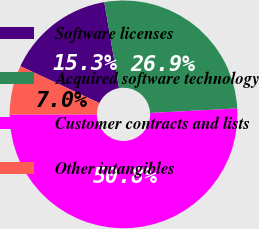Convert chart. <chart><loc_0><loc_0><loc_500><loc_500><pie_chart><fcel>Software licenses<fcel>Acquired software technology<fcel>Customer contracts and lists<fcel>Other intangibles<nl><fcel>15.35%<fcel>26.87%<fcel>50.8%<fcel>6.98%<nl></chart> 